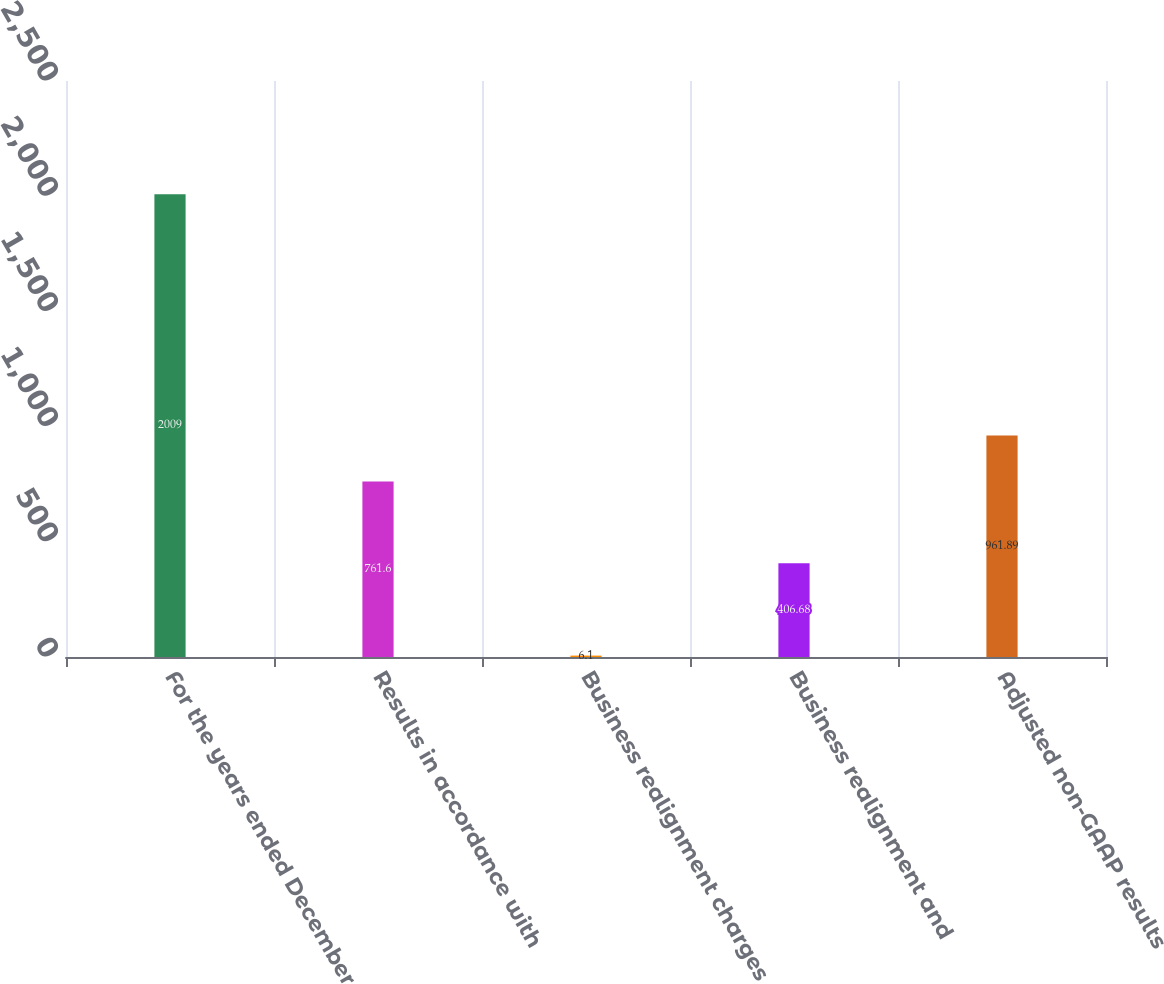Convert chart. <chart><loc_0><loc_0><loc_500><loc_500><bar_chart><fcel>For the years ended December<fcel>Results in accordance with<fcel>Business realignment charges<fcel>Business realignment and<fcel>Adjusted non-GAAP results<nl><fcel>2009<fcel>761.6<fcel>6.1<fcel>406.68<fcel>961.89<nl></chart> 